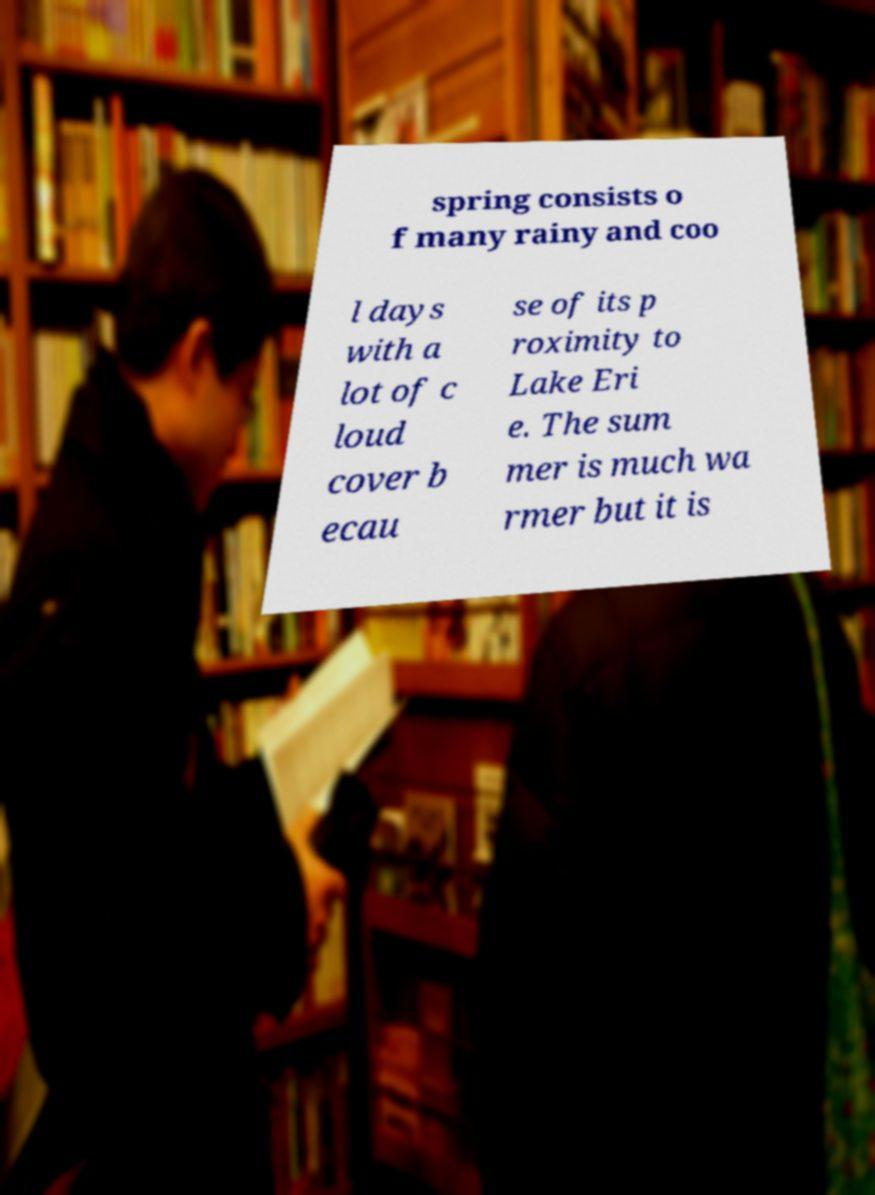Could you extract and type out the text from this image? spring consists o f many rainy and coo l days with a lot of c loud cover b ecau se of its p roximity to Lake Eri e. The sum mer is much wa rmer but it is 